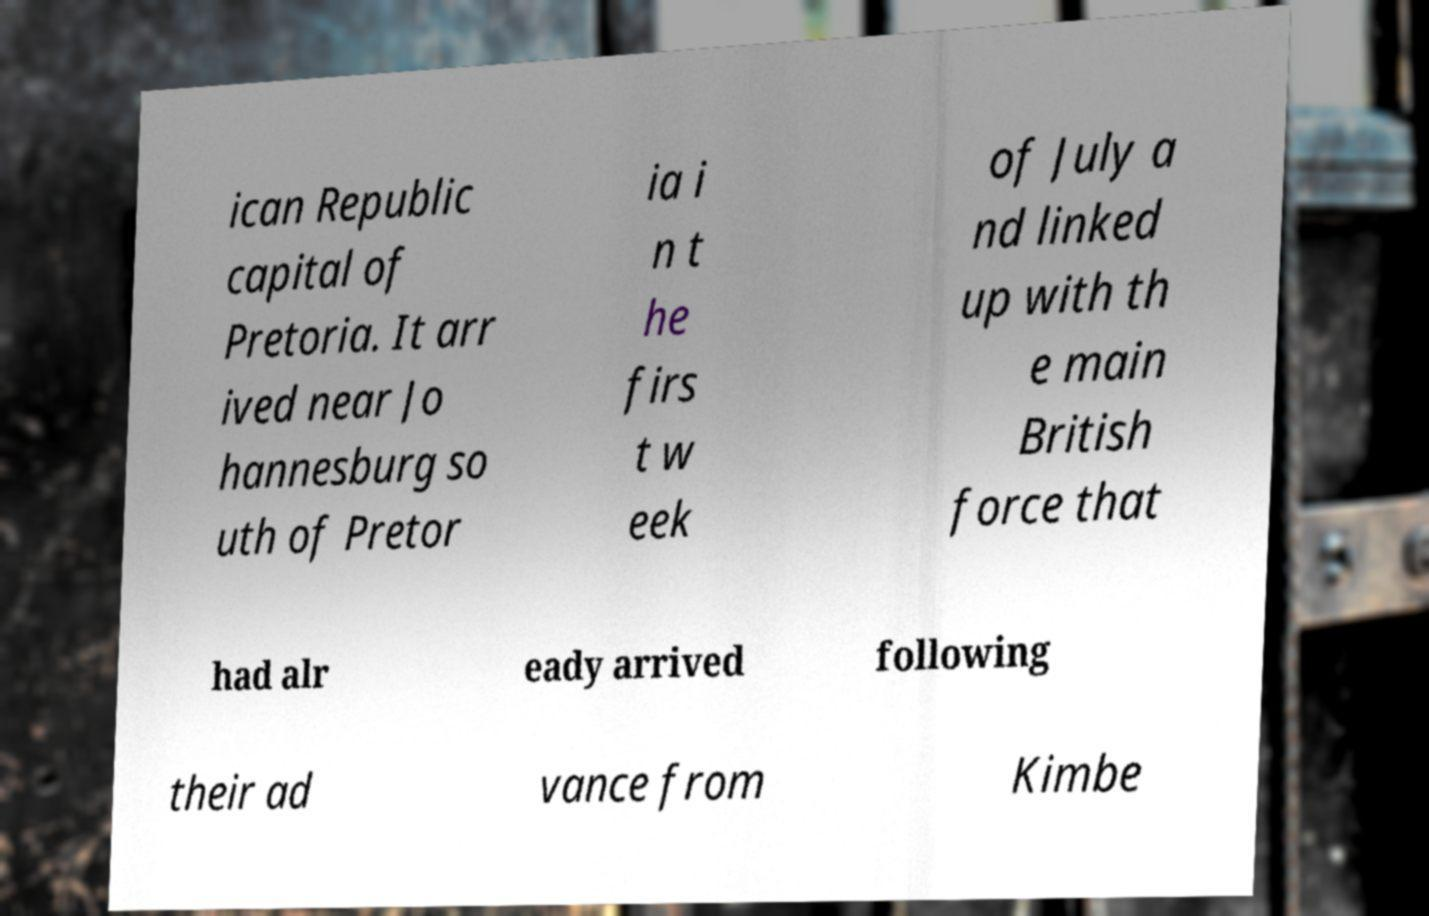Could you extract and type out the text from this image? ican Republic capital of Pretoria. It arr ived near Jo hannesburg so uth of Pretor ia i n t he firs t w eek of July a nd linked up with th e main British force that had alr eady arrived following their ad vance from Kimbe 